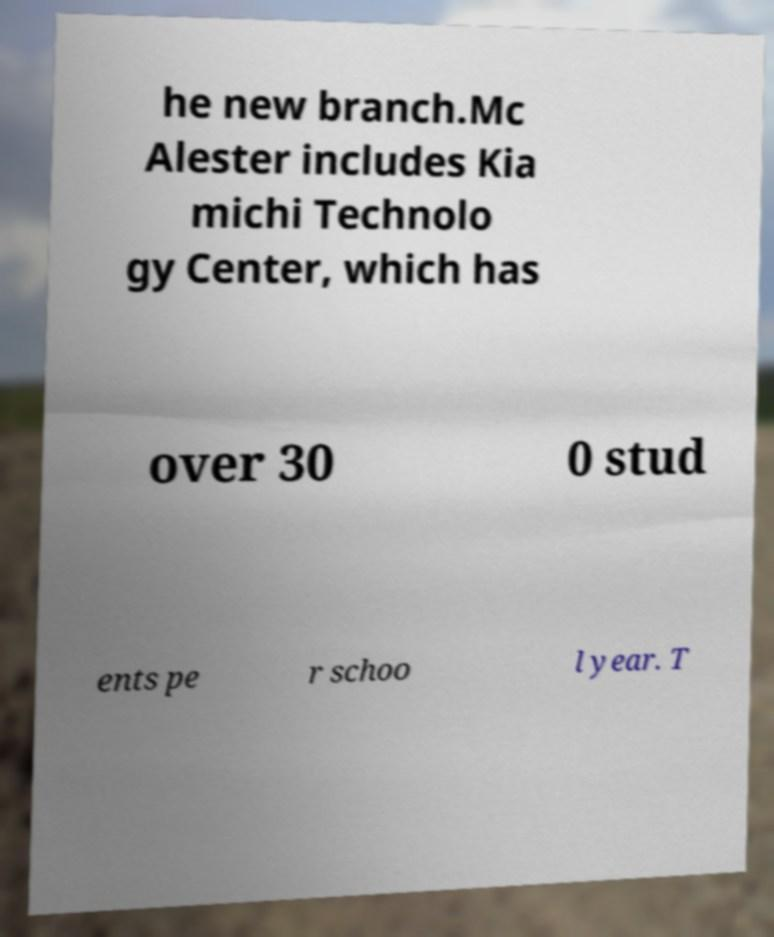I need the written content from this picture converted into text. Can you do that? he new branch.Mc Alester includes Kia michi Technolo gy Center, which has over 30 0 stud ents pe r schoo l year. T 